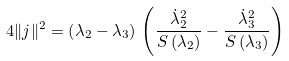Convert formula to latex. <formula><loc_0><loc_0><loc_500><loc_500>4 \| j \| ^ { 2 } = \left ( \lambda _ { 2 } - \lambda _ { 3 } \right ) \, \left ( \frac { { \dot { \lambda } _ { 2 } } ^ { 2 } } { S \left ( \lambda _ { 2 } \right ) } - \frac { { \dot { \lambda } _ { 3 } } ^ { 2 } } { S \left ( \lambda _ { 3 } \right ) } \right )</formula> 